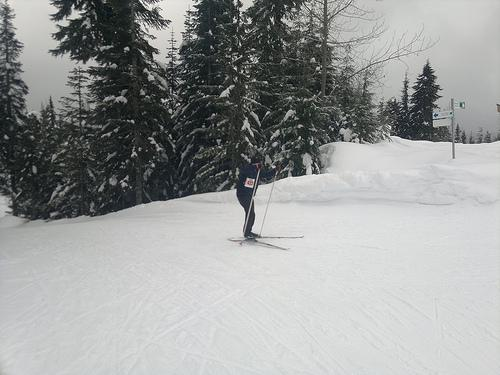Question: when do skiers come here?
Choices:
A. In the off season.
B. On spring break.
C. During the winter.
D. At Christmas.
Answer with the letter. Answer: C Question: what is this activity?
Choices:
A. Sledding.
B. Football.
C. Soccer.
D. Snow skiing.
Answer with the letter. Answer: D Question: why do they have poles?
Choices:
A. To move.
B. To push.
C. To help propel them.
D. For looks.
Answer with the letter. Answer: C Question: where is this scene?
Choices:
A. In forest.
B. Outside.
C. In the mountains.
D. Open space.
Answer with the letter. Answer: C Question: how do you ski up hill?
Choices:
A. With ski poles.
B. Pushing.
C. Slowly.
D. Stepping in a herringbone pattern.
Answer with the letter. Answer: D Question: who is wearing gloves?
Choices:
A. People.
B. The skier.
C. Men.
D. Women.
Answer with the letter. Answer: B 